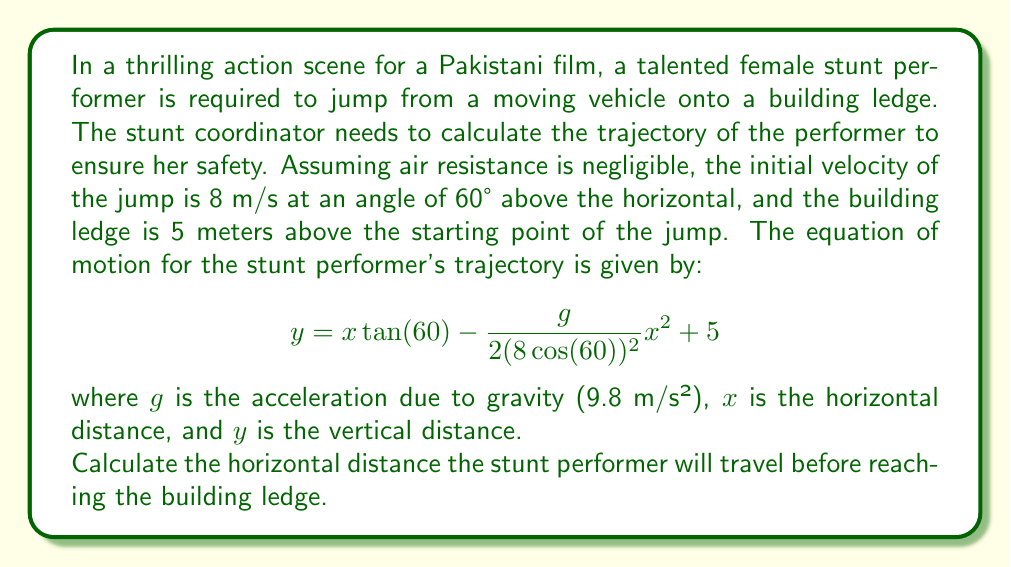Solve this math problem. To solve this problem, we need to find the value of $x$ when $y = 5$ (the height of the building ledge). Let's approach this step-by-step:

1) First, let's simplify the equation by substituting known values:
   $\tan(60°) = \sqrt{3}$
   $\cos(60°) = \frac{1}{2}$
   
   $$y = x\sqrt{3} - \frac{9.8}{2(8 \cdot \frac{1}{2})^2}x^2 + 5$$
   
   $$y = x\sqrt{3} - \frac{9.8}{16}x^2 + 5$$

2) Now, we want to find $x$ when $y = 5$. So, we can set up the equation:

   $$5 = x\sqrt{3} - \frac{9.8}{16}x^2 + 5$$

3) Simplify by subtracting 5 from both sides:

   $$0 = x\sqrt{3} - \frac{9.8}{16}x^2$$

4) Multiply both sides by 16:

   $$0 = 16x\sqrt{3} - 9.8x^2$$

5) Rearrange into standard quadratic form:

   $$9.8x^2 - 16x\sqrt{3} = 0$$

6) Factor out $x$:

   $$x(9.8x - 16\sqrt{3}) = 0$$

7) Solve for $x$:
   $x = 0$ or $9.8x - 16\sqrt{3} = 0$
   
   For the non-zero solution:
   $$x = \frac{16\sqrt{3}}{9.8} \approx 2.83$$

The solution $x = 0$ doesn't make sense in the context of the problem, so we take the positive solution.
Answer: The stunt performer will travel approximately 2.83 meters horizontally before reaching the building ledge. 